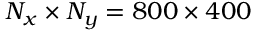<formula> <loc_0><loc_0><loc_500><loc_500>N _ { x } \times N _ { y } = 8 0 0 \times 4 0 0</formula> 